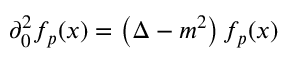<formula> <loc_0><loc_0><loc_500><loc_500>\partial _ { 0 } ^ { 2 } f _ { p } ( x ) = \left ( \Delta - m ^ { 2 } \right ) f _ { p } ( x )</formula> 